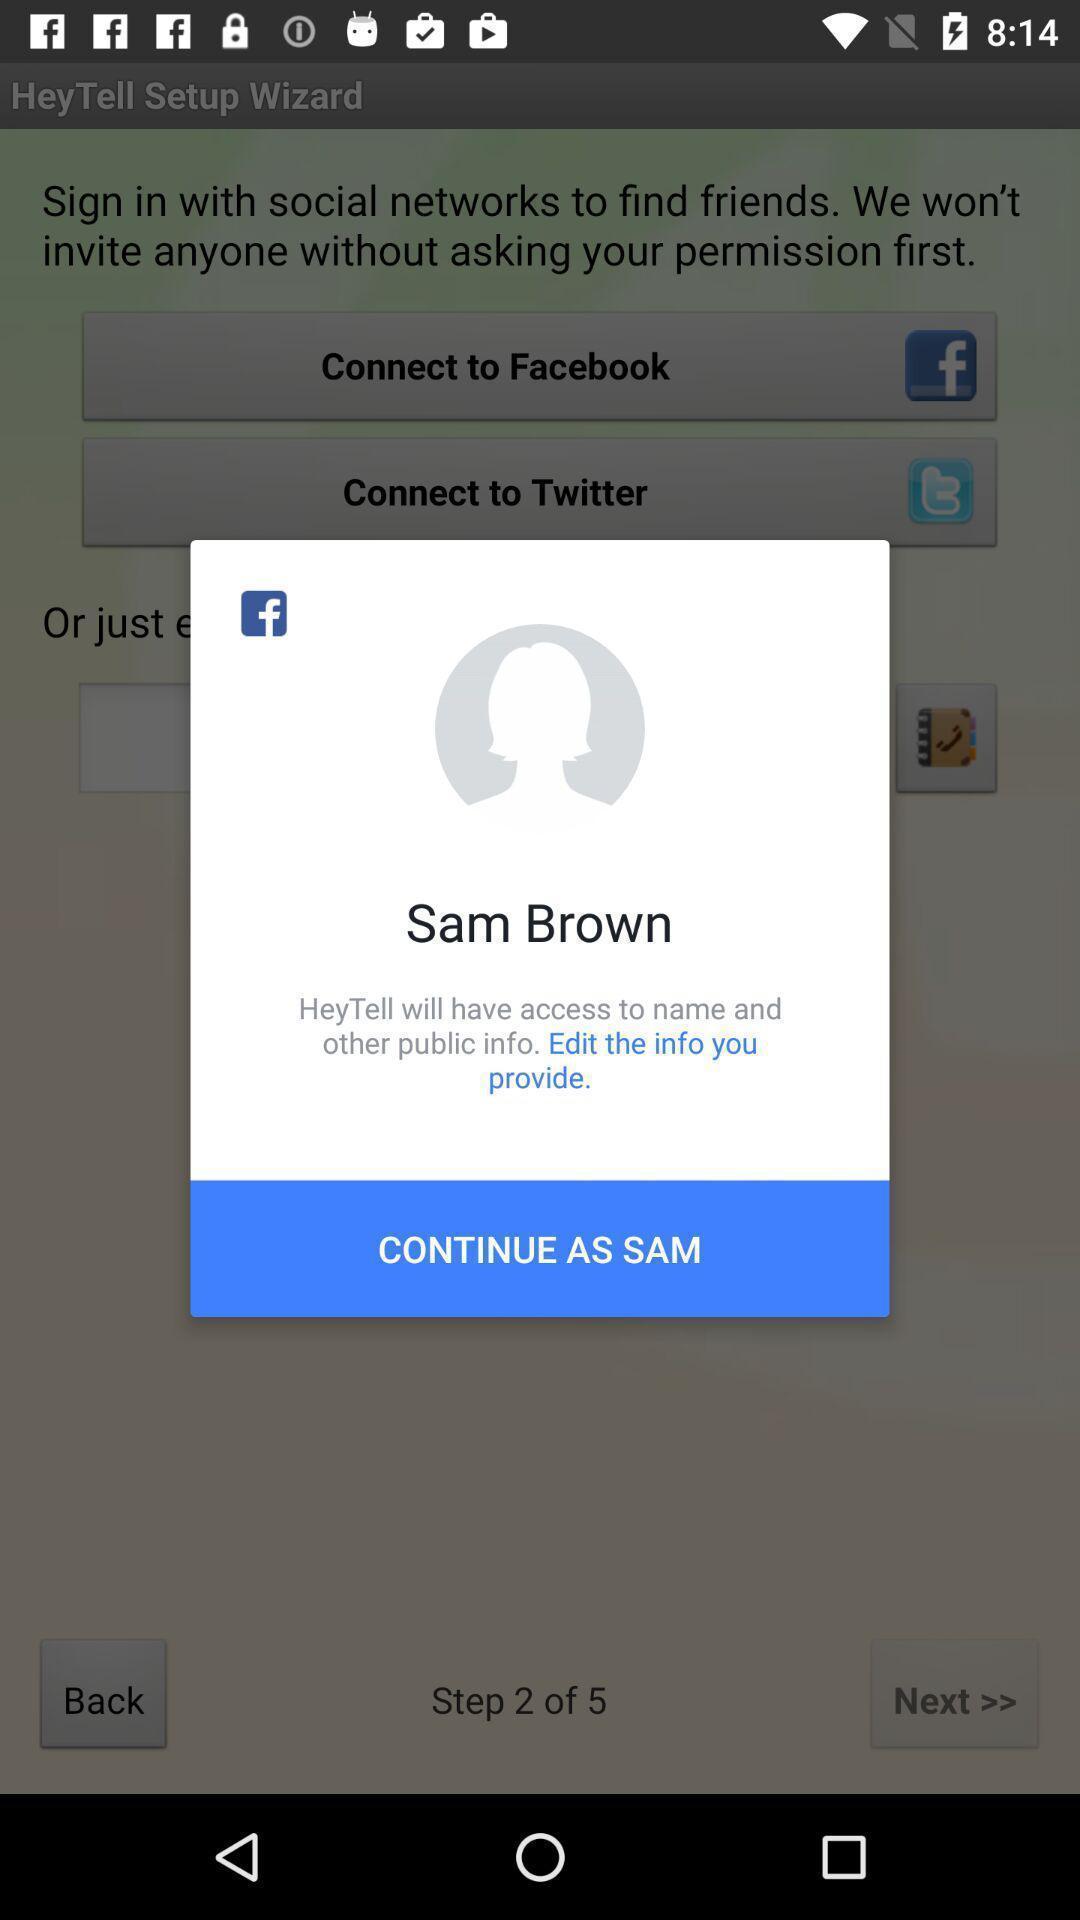Summarize the main components in this picture. Pop-up shows to continue as for the application. 